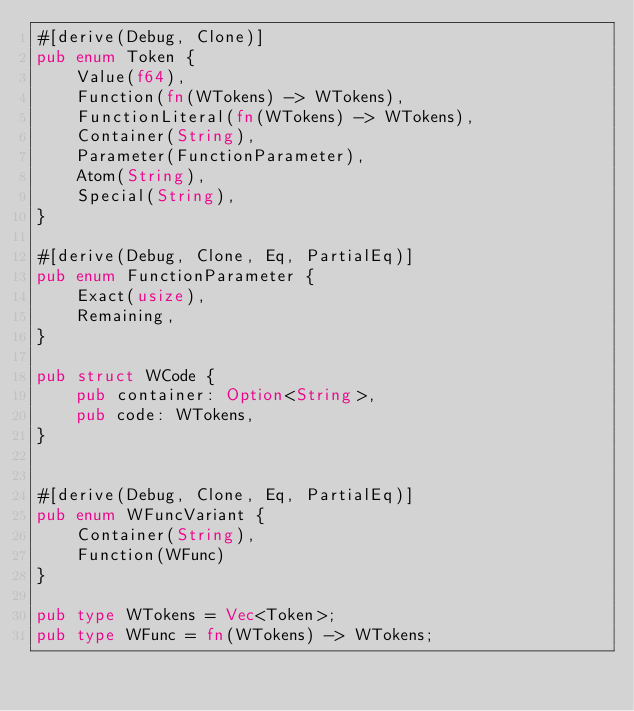<code> <loc_0><loc_0><loc_500><loc_500><_Rust_>#[derive(Debug, Clone)]
pub enum Token {
    Value(f64),
    Function(fn(WTokens) -> WTokens),
    FunctionLiteral(fn(WTokens) -> WTokens),
    Container(String),
    Parameter(FunctionParameter),
    Atom(String),
    Special(String),
}

#[derive(Debug, Clone, Eq, PartialEq)]
pub enum FunctionParameter {
    Exact(usize),
    Remaining,
}

pub struct WCode {
    pub container: Option<String>,
    pub code: WTokens,
}


#[derive(Debug, Clone, Eq, PartialEq)]
pub enum WFuncVariant {
    Container(String),
    Function(WFunc)
}

pub type WTokens = Vec<Token>;
pub type WFunc = fn(WTokens) -> WTokens;
</code> 